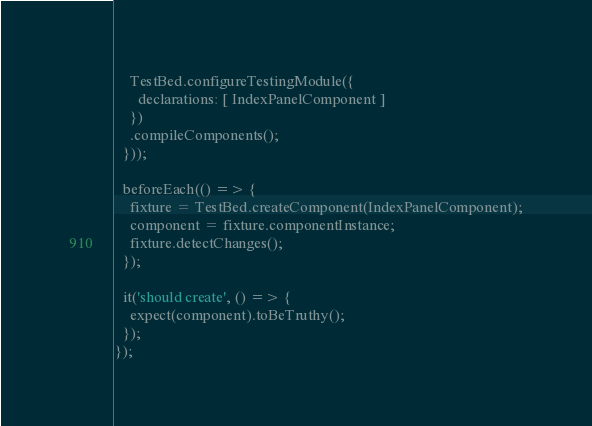Convert code to text. <code><loc_0><loc_0><loc_500><loc_500><_TypeScript_>    TestBed.configureTestingModule({
      declarations: [ IndexPanelComponent ]
    })
    .compileComponents();
  }));

  beforeEach(() => {
    fixture = TestBed.createComponent(IndexPanelComponent);
    component = fixture.componentInstance;
    fixture.detectChanges();
  });

  it('should create', () => {
    expect(component).toBeTruthy();
  });
});
</code> 